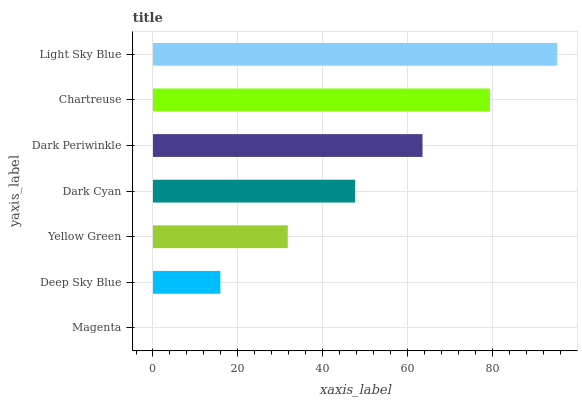Is Magenta the minimum?
Answer yes or no. Yes. Is Light Sky Blue the maximum?
Answer yes or no. Yes. Is Deep Sky Blue the minimum?
Answer yes or no. No. Is Deep Sky Blue the maximum?
Answer yes or no. No. Is Deep Sky Blue greater than Magenta?
Answer yes or no. Yes. Is Magenta less than Deep Sky Blue?
Answer yes or no. Yes. Is Magenta greater than Deep Sky Blue?
Answer yes or no. No. Is Deep Sky Blue less than Magenta?
Answer yes or no. No. Is Dark Cyan the high median?
Answer yes or no. Yes. Is Dark Cyan the low median?
Answer yes or no. Yes. Is Yellow Green the high median?
Answer yes or no. No. Is Magenta the low median?
Answer yes or no. No. 